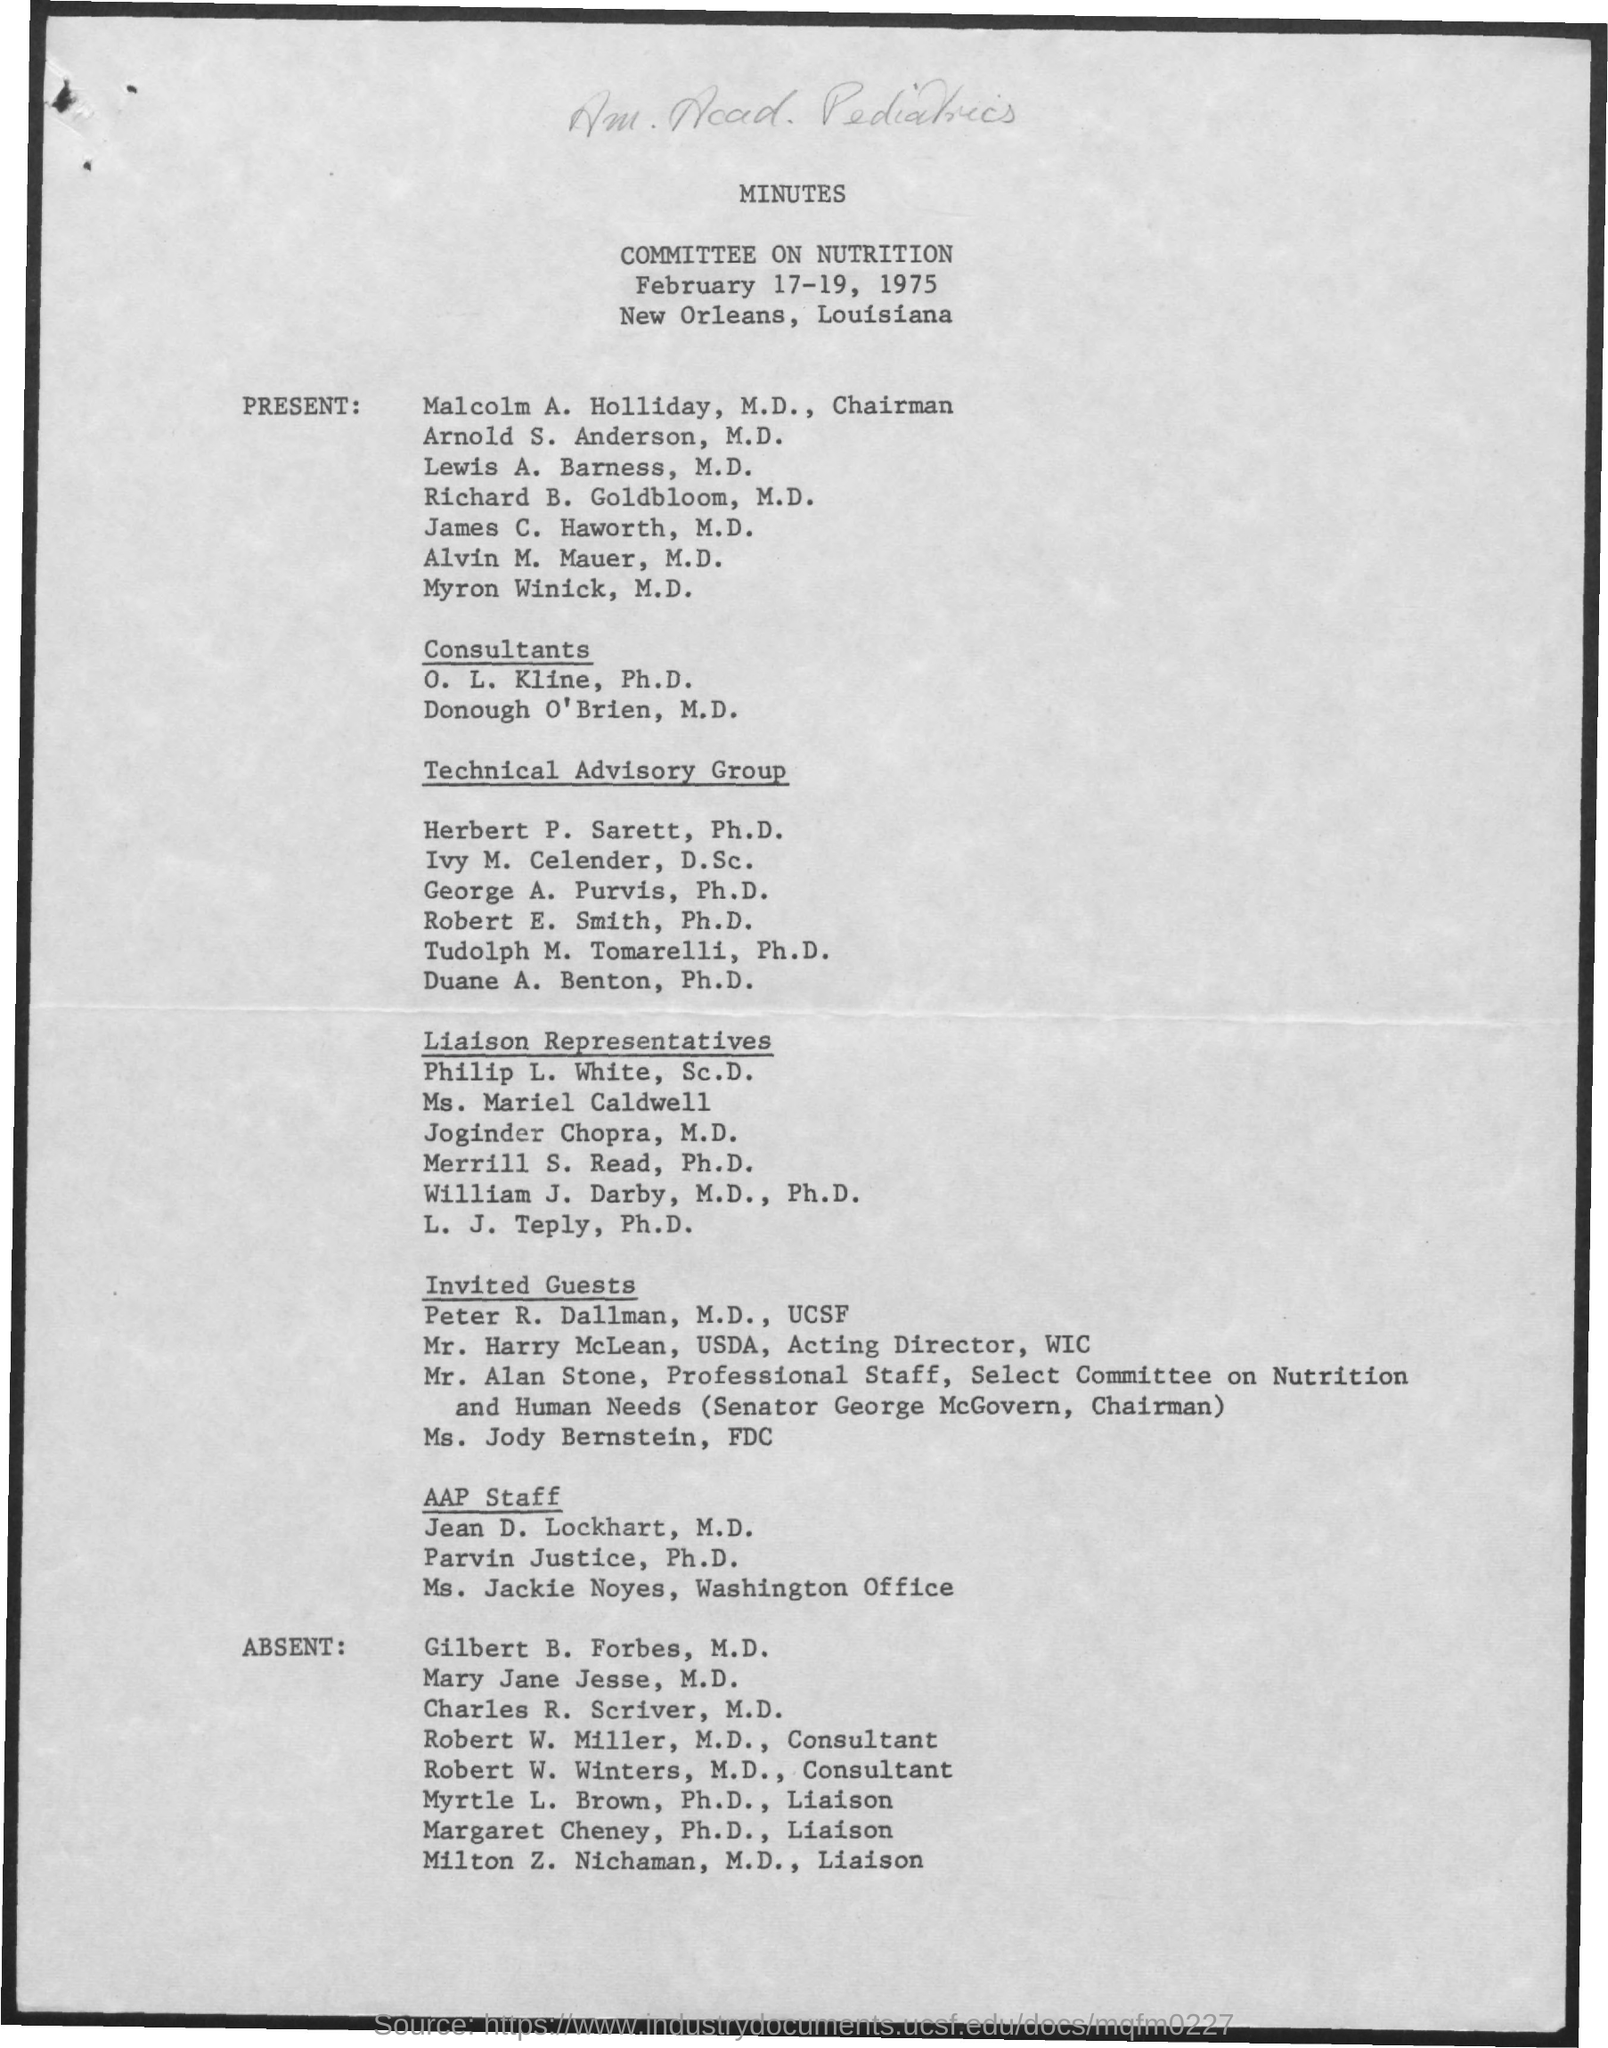Give some essential details in this illustration. Robert W. Miller's designation is that of a consultant. The second title that is not handwritten is 'Committee on Nutrition.' The Chairman is Malcolm A. Holliday. The first title that is not handwritten is 'Minutes.'  Robert W. Winters holds the designation of consultant. 